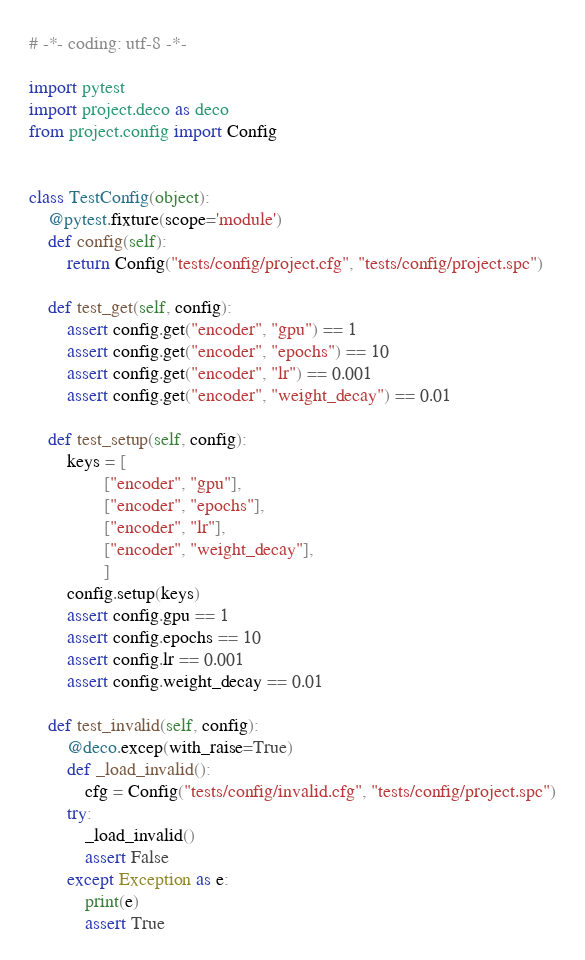<code> <loc_0><loc_0><loc_500><loc_500><_Python_># -*- coding: utf-8 -*-

import pytest
import project.deco as deco
from project.config import Config


class TestConfig(object):
    @pytest.fixture(scope='module')
    def config(self):
        return Config("tests/config/project.cfg", "tests/config/project.spc")

    def test_get(self, config):
        assert config.get("encoder", "gpu") == 1
        assert config.get("encoder", "epochs") == 10
        assert config.get("encoder", "lr") == 0.001
        assert config.get("encoder", "weight_decay") == 0.01

    def test_setup(self, config):
        keys = [
                ["encoder", "gpu"],
                ["encoder", "epochs"],
                ["encoder", "lr"],
                ["encoder", "weight_decay"],
                ]
        config.setup(keys)
        assert config.gpu == 1
        assert config.epochs == 10
        assert config.lr == 0.001
        assert config.weight_decay == 0.01

    def test_invalid(self, config):
        @deco.excep(with_raise=True)
        def _load_invalid():
            cfg = Config("tests/config/invalid.cfg", "tests/config/project.spc")
        try:
            _load_invalid()
            assert False
        except Exception as e:
            print(e)
            assert True
</code> 